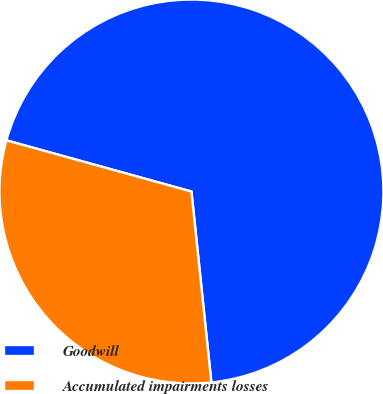Convert chart to OTSL. <chart><loc_0><loc_0><loc_500><loc_500><pie_chart><fcel>Goodwill<fcel>Accumulated impairments losses<nl><fcel>69.05%<fcel>30.95%<nl></chart> 